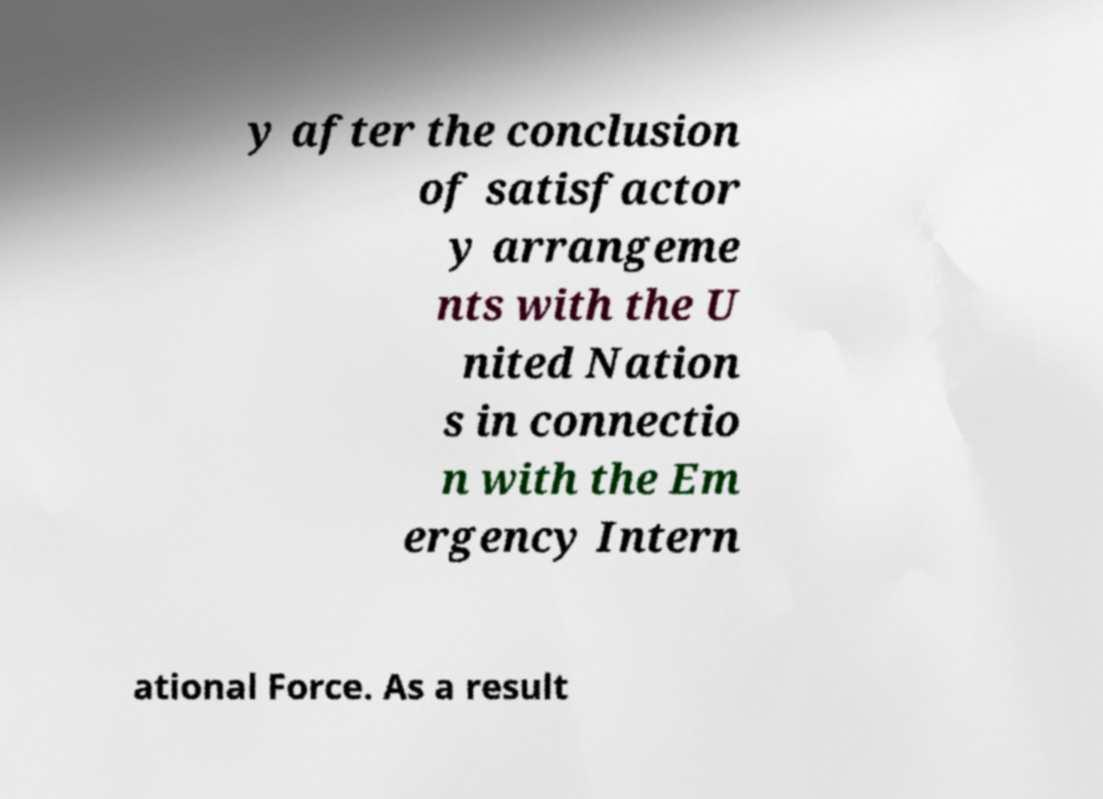I need the written content from this picture converted into text. Can you do that? y after the conclusion of satisfactor y arrangeme nts with the U nited Nation s in connectio n with the Em ergency Intern ational Force. As a result 